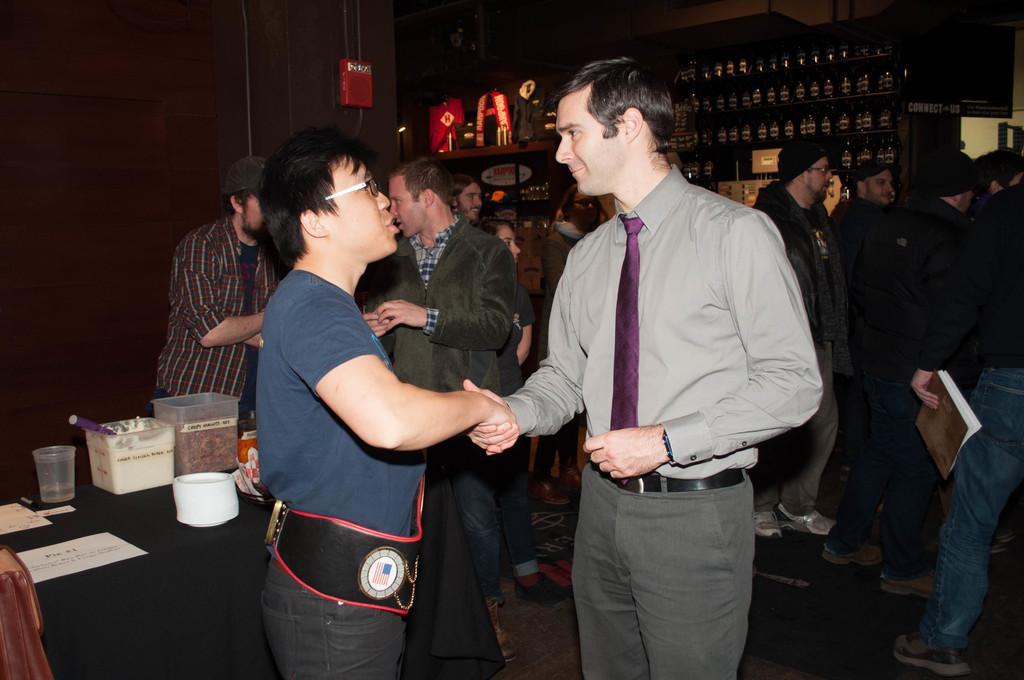How would you summarize this image in a sentence or two? There are two men shaking their hands in the foreground area of the image, there are people, bottles, posters and other objects in the background. 